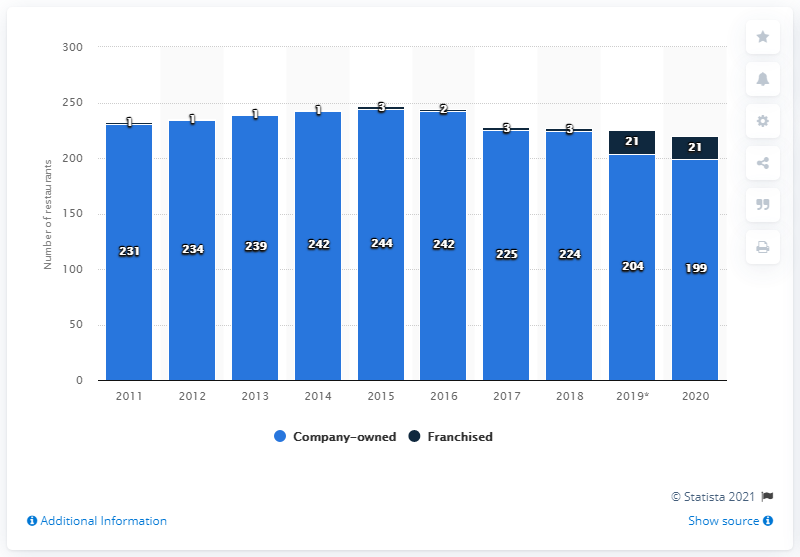Point out several critical features in this image. In 2020, the number of company-owned restaurants at Carrabba's Italian Grill was 199. Carrabba's Italian Grill had 21 franchise restaurants in 2020. 